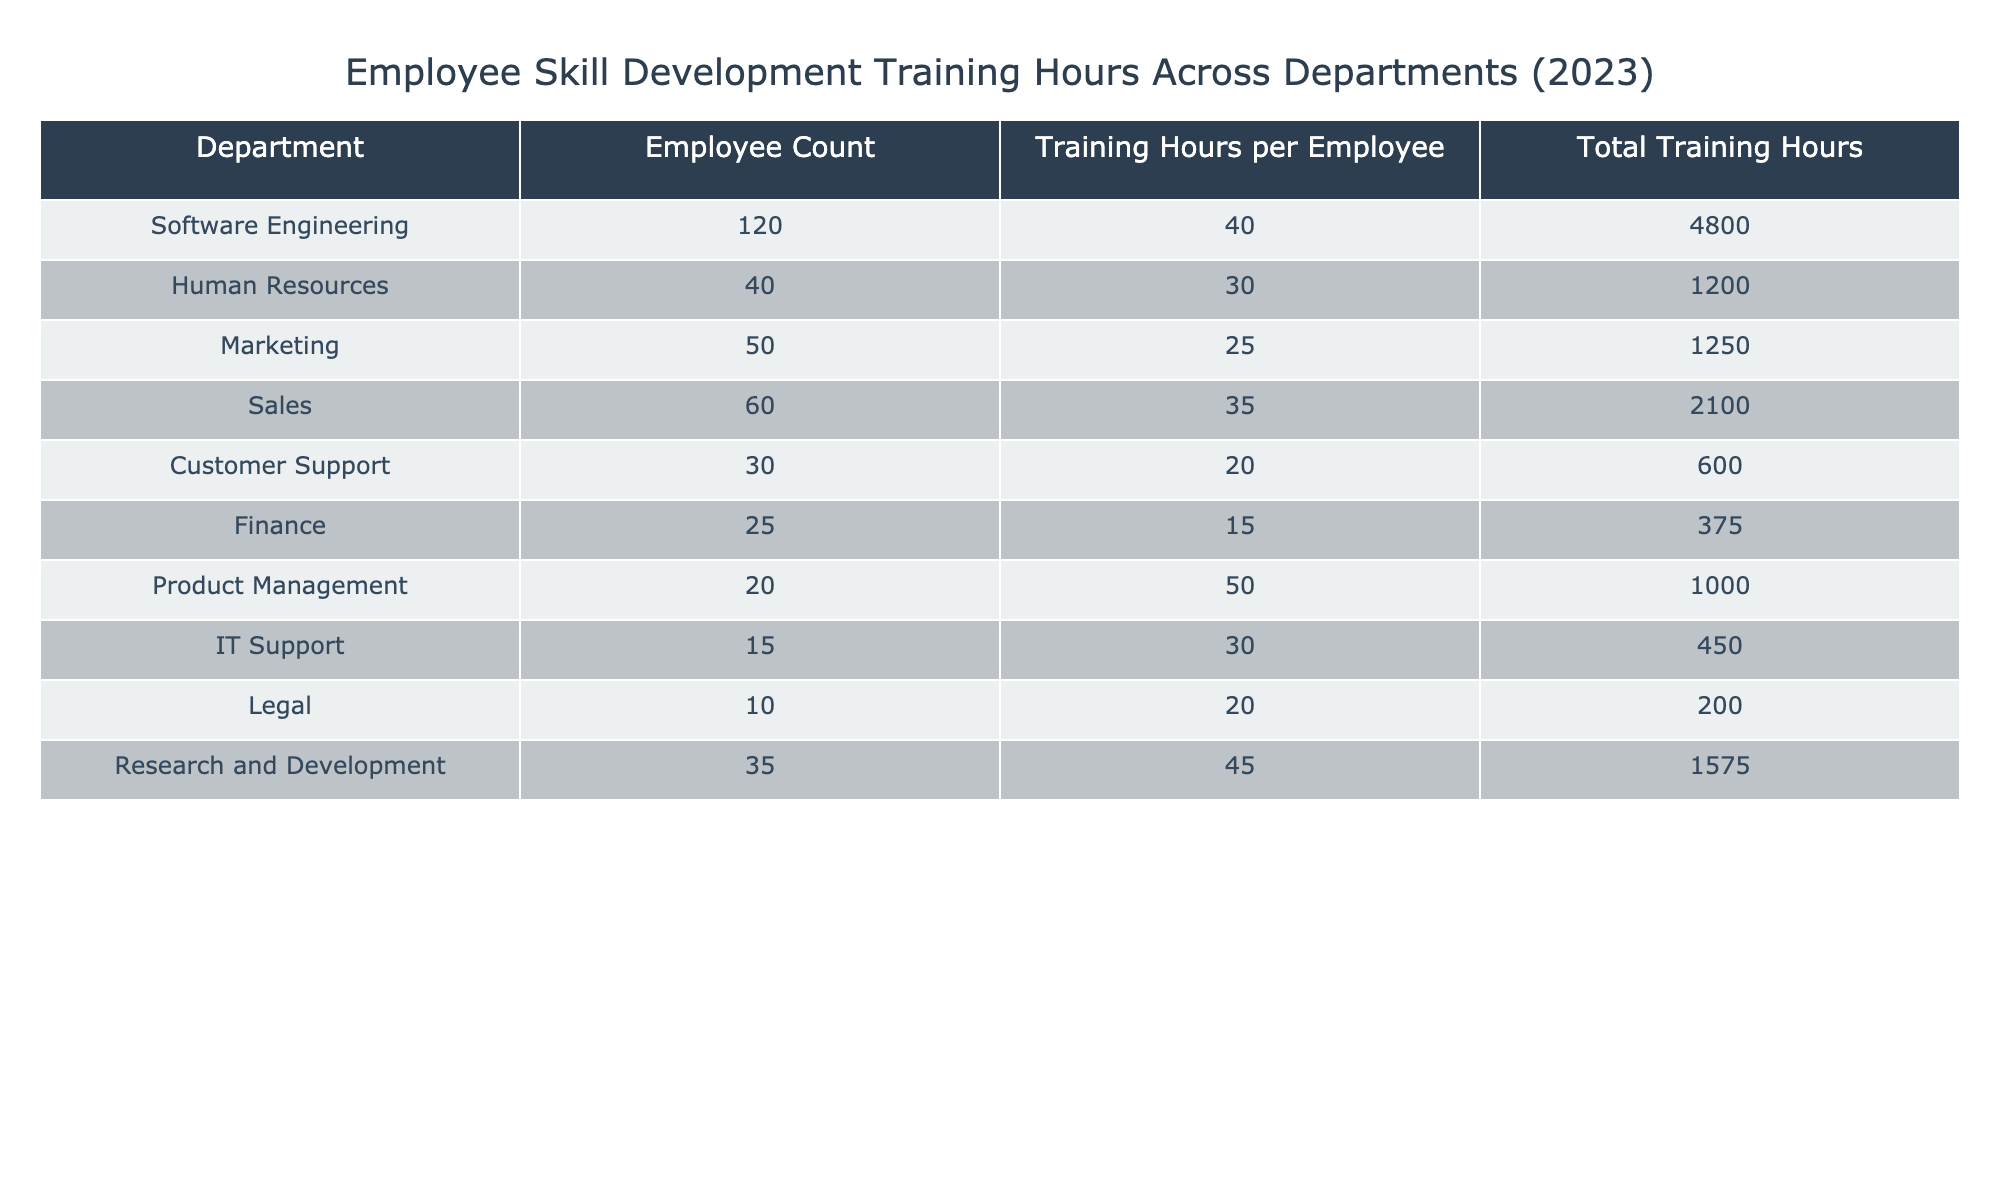What's the department with the highest total training hours? Looking at the "Total Training Hours" column, the department "Software Engineering" has the highest value at 4800 hours.
Answer: Software Engineering What is the employee count in the Finance department? Referring to the "Employee Count" column, the Finance department has a count of 25 employees.
Answer: 25 How many total training hours were dedicated to Customer Support? The "Total Training Hours" for Customer Support is listed as 600 hours directly in the table.
Answer: 600 What is the average training hours per employee across all departments? First, we sum up all "Total Training Hours" (4800 + 1200 + 1250 + 2100 + 600 + 375 + 1000 + 450 + 200 + 1575 = 10050 hours). The total employee count is 410, so we divide 10050 by 410, which equals approximately 24.5.
Answer: 24.5 Is the average training hours per employee in Product Management more than 40? The training hours per employee in Product Management are 50, which is greater than 40.
Answer: Yes What is the difference in total training hours between Software Engineering and Sales? Total hours in Software Engineering are 4800, and in Sales, they are 2100. The difference is 4800 - 2100 = 2700 hours.
Answer: 2700 Which department has fewer employee counts: Legal or IT Support? Legal has 10 employees while IT Support has 15 employees, thus Legal has fewer employees.
Answer: Legal What percentage of the total training hours was spent in Human Resources? Total training hours across all departments is 10050. The training hours in Human Resources are 1200. To find the percentage, we calculate (1200/10050) * 100 = approximately 11.95%.
Answer: 11.95% Is it true that Research and Development has more training hours per employee than Finance? Research and Development has 45 hours per employee versus 15 in Finance, confirming that it is true.
Answer: Yes 